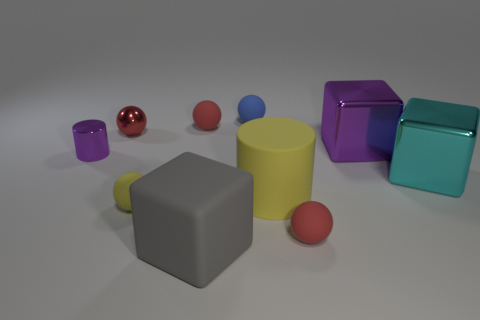Subtract all large matte blocks. How many blocks are left? 2 Subtract all yellow spheres. How many spheres are left? 4 Subtract 1 cylinders. How many cylinders are left? 1 Subtract 0 red cubes. How many objects are left? 10 Subtract all cylinders. How many objects are left? 8 Subtract all yellow blocks. Subtract all purple balls. How many blocks are left? 3 Subtract all red blocks. How many cyan balls are left? 0 Subtract all tiny spheres. Subtract all large objects. How many objects are left? 1 Add 9 cyan blocks. How many cyan blocks are left? 10 Add 9 tiny blue shiny cubes. How many tiny blue shiny cubes exist? 9 